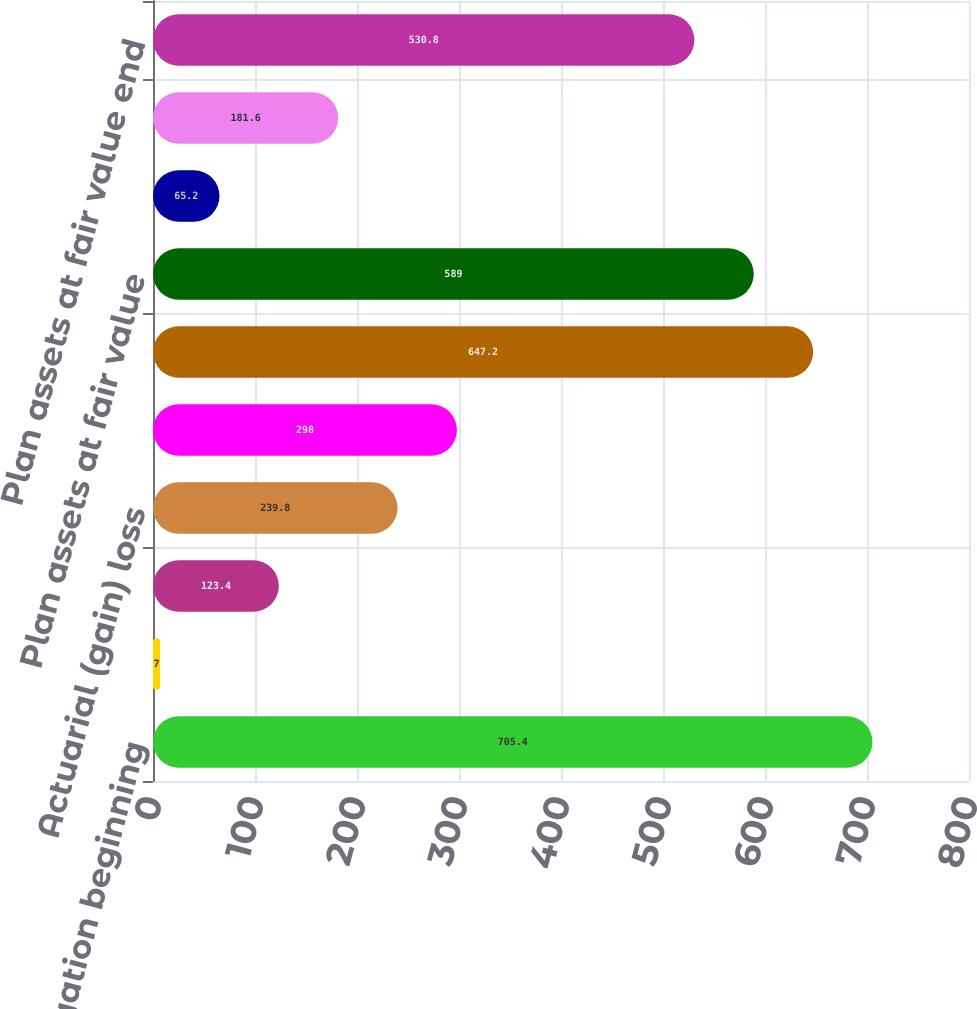Convert chart. <chart><loc_0><loc_0><loc_500><loc_500><bar_chart><fcel>Benefit Obligation beginning<fcel>Service cost<fcel>Interest cost<fcel>Actuarial (gain) loss<fcel>Gross benefits paid<fcel>Benefit Obligation end of<fcel>Plan assets at fair value<fcel>Actual return on plan assets<fcel>Employer contributions<fcel>Plan assets at fair value end<nl><fcel>705.4<fcel>7<fcel>123.4<fcel>239.8<fcel>298<fcel>647.2<fcel>589<fcel>65.2<fcel>181.6<fcel>530.8<nl></chart> 